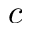<formula> <loc_0><loc_0><loc_500><loc_500>c</formula> 